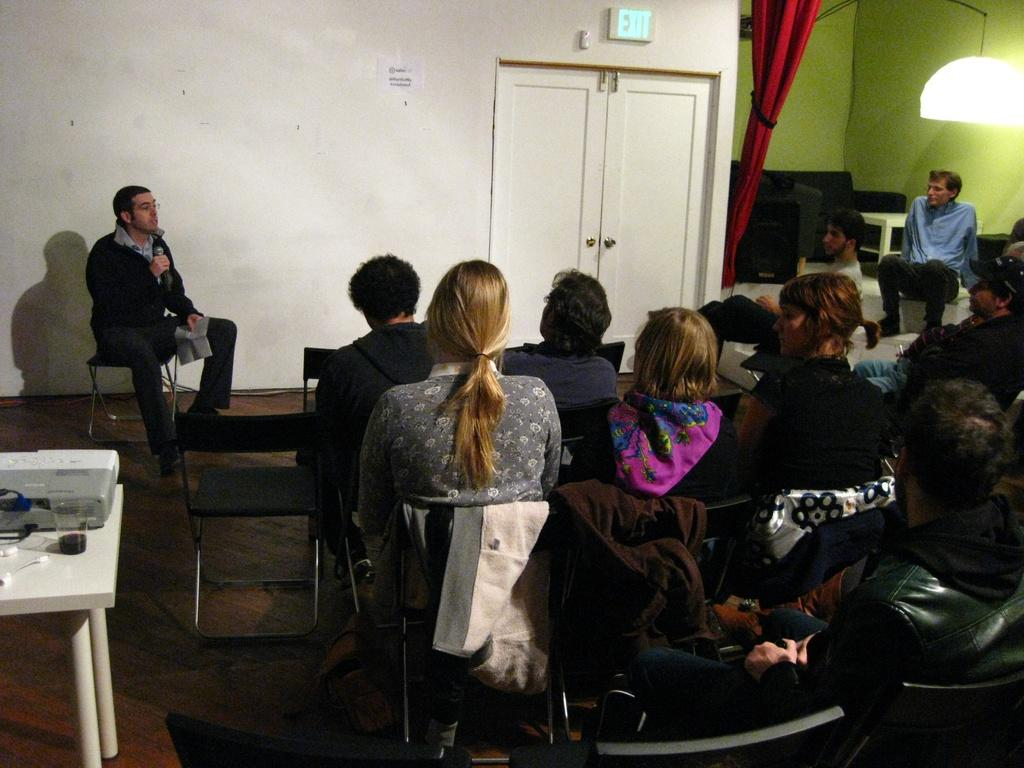How many people are in the image? There is a group of people in the image, but the exact number cannot be determined from the provided facts. What object is on the table in the image? There is a glass on a table in the image. What is the man in the image holding? The man in the image is holding a mic. How many cakes are on the table in the image? There is no mention of cakes in the provided facts, so we cannot determine their presence or quantity in the image. 